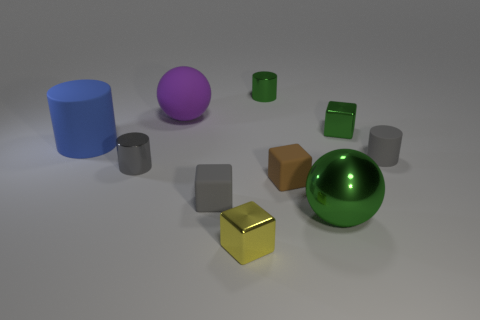Subtract all gray shiny cylinders. How many cylinders are left? 3 Subtract 1 balls. How many balls are left? 1 Subtract all cyan balls. How many gray cylinders are left? 2 Subtract all green cubes. How many cubes are left? 3 Subtract 0 purple cylinders. How many objects are left? 10 Subtract all balls. How many objects are left? 8 Subtract all gray cylinders. Subtract all green balls. How many cylinders are left? 2 Subtract all tiny green objects. Subtract all large green objects. How many objects are left? 7 Add 4 big shiny objects. How many big shiny objects are left? 5 Add 4 blocks. How many blocks exist? 8 